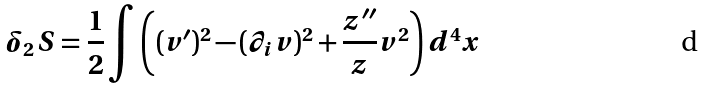Convert formula to latex. <formula><loc_0><loc_0><loc_500><loc_500>\delta _ { 2 } S = \frac { 1 } { 2 } \int \left ( ( v ^ { \prime } ) ^ { 2 } - ( \partial _ { i } v ) ^ { 2 } + \frac { z { ^ { \prime \prime } } } { z } v ^ { 2 } \right ) d ^ { 4 } x</formula> 